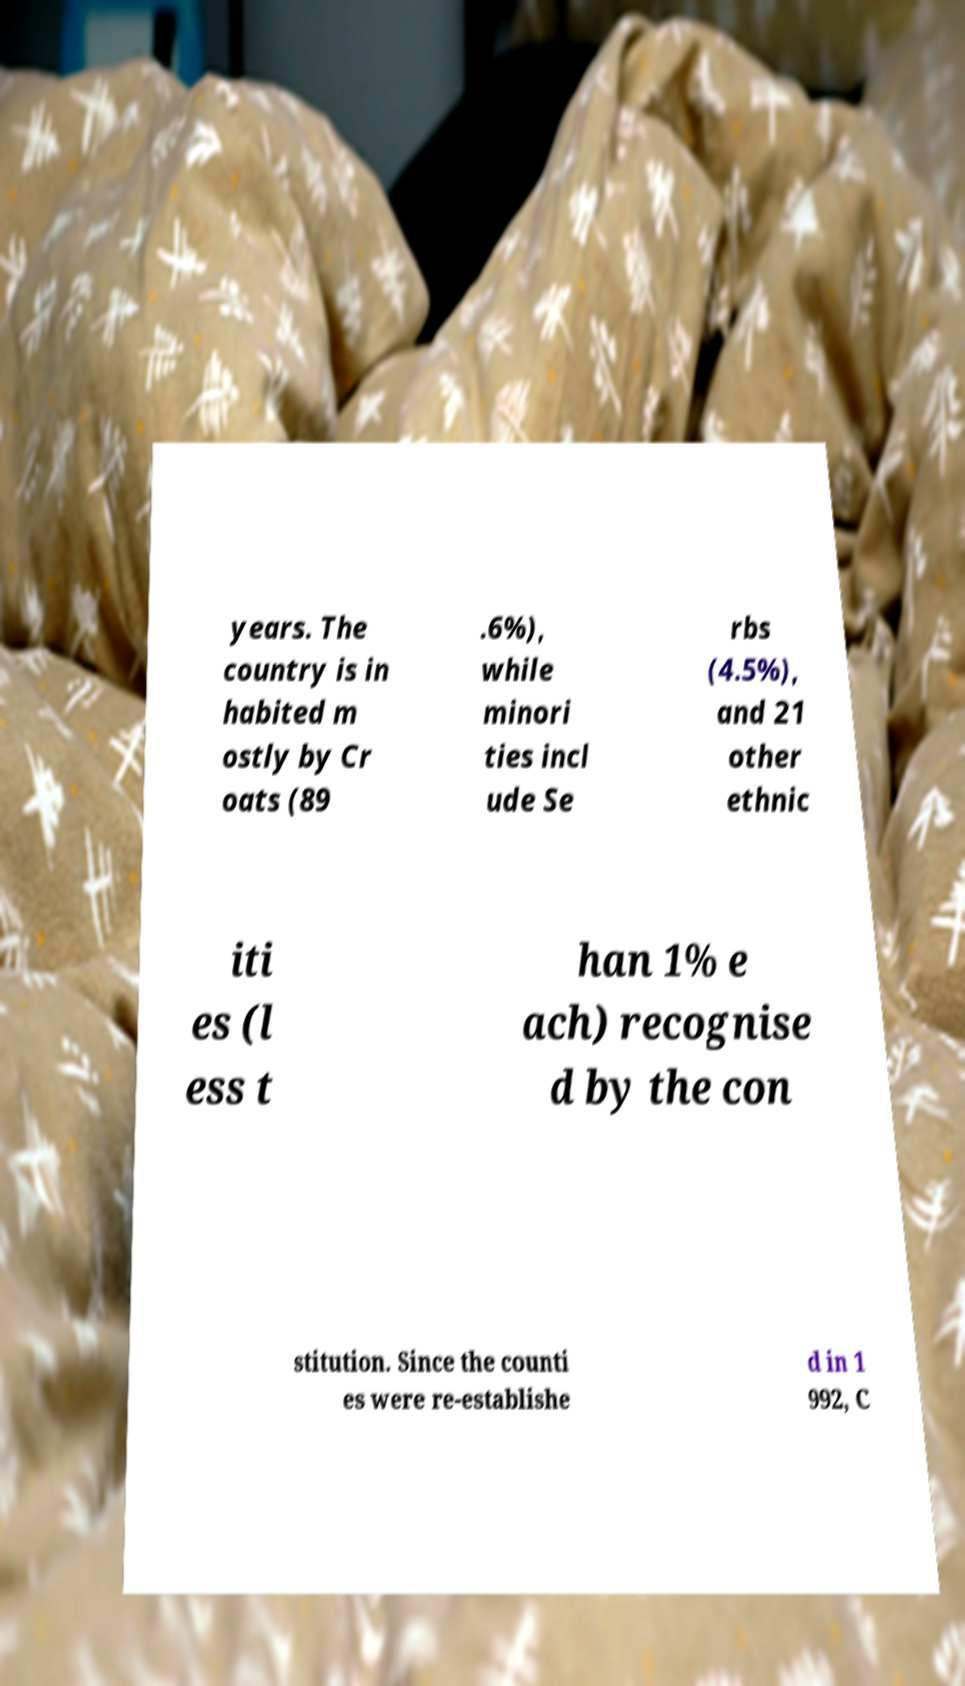What messages or text are displayed in this image? I need them in a readable, typed format. years. The country is in habited m ostly by Cr oats (89 .6%), while minori ties incl ude Se rbs (4.5%), and 21 other ethnic iti es (l ess t han 1% e ach) recognise d by the con stitution. Since the counti es were re-establishe d in 1 992, C 